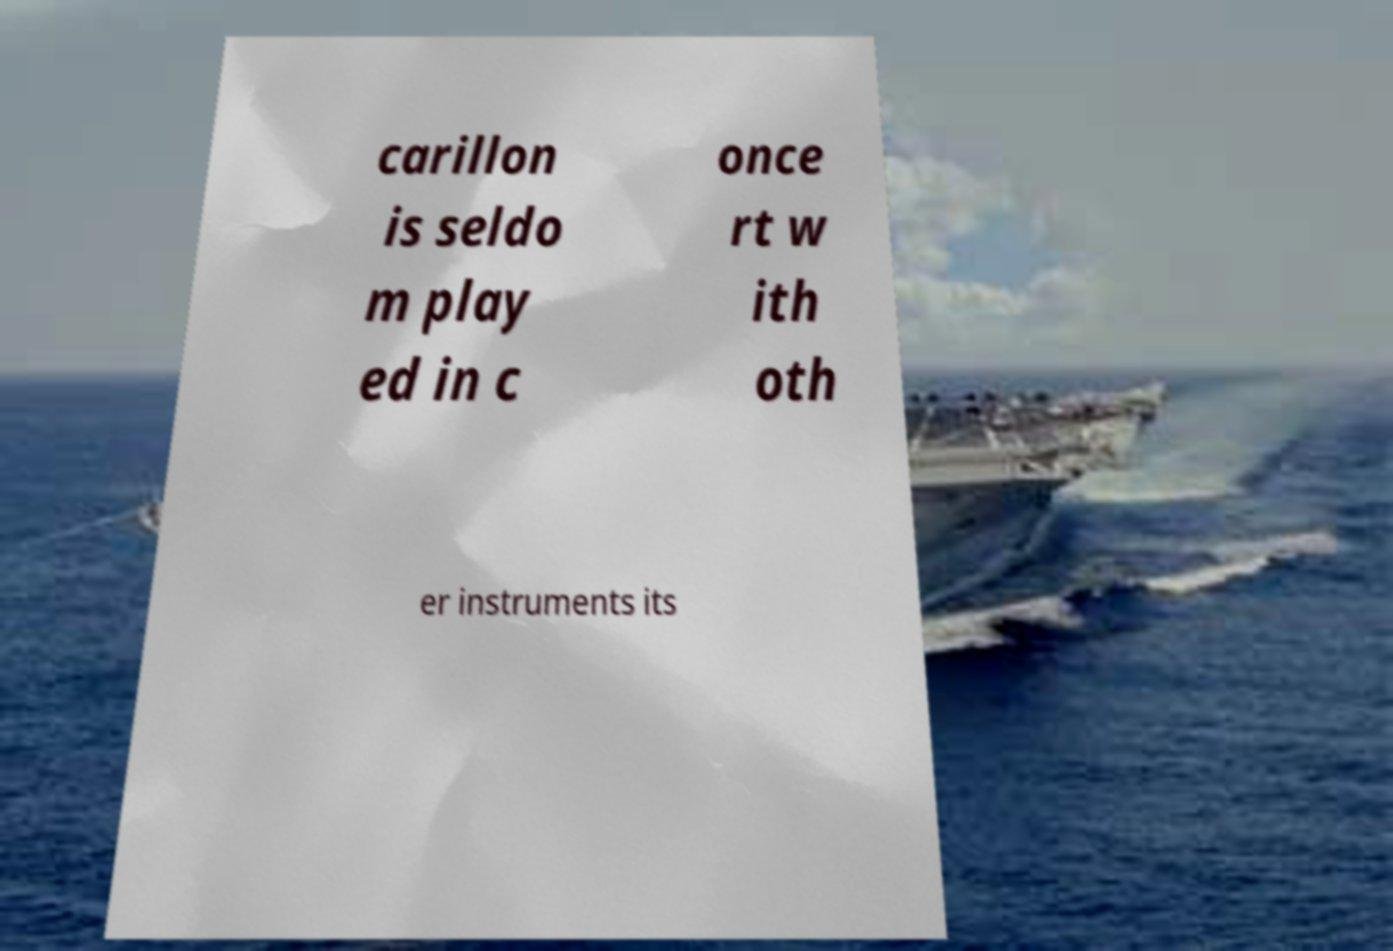Please read and relay the text visible in this image. What does it say? carillon is seldo m play ed in c once rt w ith oth er instruments its 